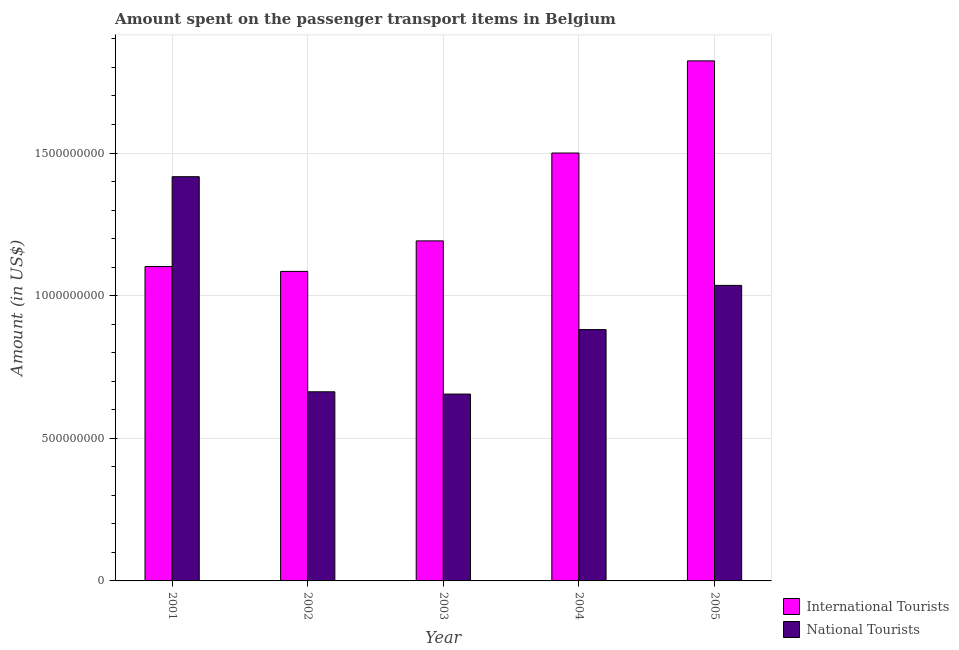How many different coloured bars are there?
Provide a succinct answer. 2. Are the number of bars on each tick of the X-axis equal?
Make the answer very short. Yes. How many bars are there on the 4th tick from the right?
Your answer should be compact. 2. In how many cases, is the number of bars for a given year not equal to the number of legend labels?
Offer a very short reply. 0. What is the amount spent on transport items of international tourists in 2002?
Your answer should be compact. 1.08e+09. Across all years, what is the maximum amount spent on transport items of national tourists?
Offer a very short reply. 1.42e+09. Across all years, what is the minimum amount spent on transport items of international tourists?
Make the answer very short. 1.08e+09. In which year was the amount spent on transport items of national tourists minimum?
Give a very brief answer. 2003. What is the total amount spent on transport items of international tourists in the graph?
Provide a succinct answer. 6.70e+09. What is the difference between the amount spent on transport items of international tourists in 2001 and that in 2005?
Offer a very short reply. -7.21e+08. What is the difference between the amount spent on transport items of national tourists in 2005 and the amount spent on transport items of international tourists in 2004?
Your answer should be compact. 1.55e+08. What is the average amount spent on transport items of international tourists per year?
Provide a succinct answer. 1.34e+09. In the year 2004, what is the difference between the amount spent on transport items of international tourists and amount spent on transport items of national tourists?
Offer a terse response. 0. In how many years, is the amount spent on transport items of international tourists greater than 300000000 US$?
Ensure brevity in your answer.  5. What is the ratio of the amount spent on transport items of international tourists in 2004 to that in 2005?
Your answer should be very brief. 0.82. Is the amount spent on transport items of international tourists in 2002 less than that in 2004?
Your response must be concise. Yes. What is the difference between the highest and the second highest amount spent on transport items of national tourists?
Ensure brevity in your answer.  3.81e+08. What is the difference between the highest and the lowest amount spent on transport items of international tourists?
Offer a very short reply. 7.38e+08. What does the 1st bar from the left in 2005 represents?
Provide a succinct answer. International Tourists. What does the 2nd bar from the right in 2002 represents?
Your answer should be very brief. International Tourists. How many bars are there?
Make the answer very short. 10. Are all the bars in the graph horizontal?
Your answer should be very brief. No. How many years are there in the graph?
Offer a very short reply. 5. What is the difference between two consecutive major ticks on the Y-axis?
Provide a short and direct response. 5.00e+08. Are the values on the major ticks of Y-axis written in scientific E-notation?
Offer a very short reply. No. Does the graph contain any zero values?
Keep it short and to the point. No. Where does the legend appear in the graph?
Offer a terse response. Bottom right. How are the legend labels stacked?
Keep it short and to the point. Vertical. What is the title of the graph?
Your answer should be very brief. Amount spent on the passenger transport items in Belgium. What is the label or title of the X-axis?
Provide a short and direct response. Year. What is the label or title of the Y-axis?
Keep it short and to the point. Amount (in US$). What is the Amount (in US$) in International Tourists in 2001?
Offer a very short reply. 1.10e+09. What is the Amount (in US$) of National Tourists in 2001?
Your answer should be very brief. 1.42e+09. What is the Amount (in US$) of International Tourists in 2002?
Offer a terse response. 1.08e+09. What is the Amount (in US$) of National Tourists in 2002?
Provide a short and direct response. 6.63e+08. What is the Amount (in US$) of International Tourists in 2003?
Keep it short and to the point. 1.19e+09. What is the Amount (in US$) of National Tourists in 2003?
Provide a succinct answer. 6.55e+08. What is the Amount (in US$) in International Tourists in 2004?
Your answer should be very brief. 1.50e+09. What is the Amount (in US$) of National Tourists in 2004?
Give a very brief answer. 8.81e+08. What is the Amount (in US$) in International Tourists in 2005?
Offer a terse response. 1.82e+09. What is the Amount (in US$) of National Tourists in 2005?
Your answer should be very brief. 1.04e+09. Across all years, what is the maximum Amount (in US$) in International Tourists?
Provide a succinct answer. 1.82e+09. Across all years, what is the maximum Amount (in US$) of National Tourists?
Your answer should be compact. 1.42e+09. Across all years, what is the minimum Amount (in US$) of International Tourists?
Keep it short and to the point. 1.08e+09. Across all years, what is the minimum Amount (in US$) in National Tourists?
Keep it short and to the point. 6.55e+08. What is the total Amount (in US$) of International Tourists in the graph?
Provide a short and direct response. 6.70e+09. What is the total Amount (in US$) of National Tourists in the graph?
Ensure brevity in your answer.  4.65e+09. What is the difference between the Amount (in US$) in International Tourists in 2001 and that in 2002?
Make the answer very short. 1.70e+07. What is the difference between the Amount (in US$) of National Tourists in 2001 and that in 2002?
Offer a very short reply. 7.54e+08. What is the difference between the Amount (in US$) of International Tourists in 2001 and that in 2003?
Your answer should be very brief. -9.00e+07. What is the difference between the Amount (in US$) in National Tourists in 2001 and that in 2003?
Your answer should be compact. 7.62e+08. What is the difference between the Amount (in US$) in International Tourists in 2001 and that in 2004?
Provide a succinct answer. -3.98e+08. What is the difference between the Amount (in US$) in National Tourists in 2001 and that in 2004?
Provide a short and direct response. 5.36e+08. What is the difference between the Amount (in US$) in International Tourists in 2001 and that in 2005?
Provide a short and direct response. -7.21e+08. What is the difference between the Amount (in US$) in National Tourists in 2001 and that in 2005?
Make the answer very short. 3.81e+08. What is the difference between the Amount (in US$) of International Tourists in 2002 and that in 2003?
Your response must be concise. -1.07e+08. What is the difference between the Amount (in US$) of International Tourists in 2002 and that in 2004?
Your answer should be compact. -4.15e+08. What is the difference between the Amount (in US$) of National Tourists in 2002 and that in 2004?
Your response must be concise. -2.18e+08. What is the difference between the Amount (in US$) of International Tourists in 2002 and that in 2005?
Keep it short and to the point. -7.38e+08. What is the difference between the Amount (in US$) of National Tourists in 2002 and that in 2005?
Your answer should be very brief. -3.73e+08. What is the difference between the Amount (in US$) in International Tourists in 2003 and that in 2004?
Offer a very short reply. -3.08e+08. What is the difference between the Amount (in US$) of National Tourists in 2003 and that in 2004?
Your answer should be compact. -2.26e+08. What is the difference between the Amount (in US$) in International Tourists in 2003 and that in 2005?
Your response must be concise. -6.31e+08. What is the difference between the Amount (in US$) in National Tourists in 2003 and that in 2005?
Offer a terse response. -3.81e+08. What is the difference between the Amount (in US$) of International Tourists in 2004 and that in 2005?
Your response must be concise. -3.23e+08. What is the difference between the Amount (in US$) of National Tourists in 2004 and that in 2005?
Make the answer very short. -1.55e+08. What is the difference between the Amount (in US$) of International Tourists in 2001 and the Amount (in US$) of National Tourists in 2002?
Provide a succinct answer. 4.39e+08. What is the difference between the Amount (in US$) in International Tourists in 2001 and the Amount (in US$) in National Tourists in 2003?
Offer a terse response. 4.47e+08. What is the difference between the Amount (in US$) of International Tourists in 2001 and the Amount (in US$) of National Tourists in 2004?
Provide a short and direct response. 2.21e+08. What is the difference between the Amount (in US$) in International Tourists in 2001 and the Amount (in US$) in National Tourists in 2005?
Your response must be concise. 6.60e+07. What is the difference between the Amount (in US$) of International Tourists in 2002 and the Amount (in US$) of National Tourists in 2003?
Provide a succinct answer. 4.30e+08. What is the difference between the Amount (in US$) in International Tourists in 2002 and the Amount (in US$) in National Tourists in 2004?
Provide a short and direct response. 2.04e+08. What is the difference between the Amount (in US$) in International Tourists in 2002 and the Amount (in US$) in National Tourists in 2005?
Offer a very short reply. 4.90e+07. What is the difference between the Amount (in US$) in International Tourists in 2003 and the Amount (in US$) in National Tourists in 2004?
Offer a terse response. 3.11e+08. What is the difference between the Amount (in US$) in International Tourists in 2003 and the Amount (in US$) in National Tourists in 2005?
Give a very brief answer. 1.56e+08. What is the difference between the Amount (in US$) in International Tourists in 2004 and the Amount (in US$) in National Tourists in 2005?
Make the answer very short. 4.64e+08. What is the average Amount (in US$) of International Tourists per year?
Your answer should be very brief. 1.34e+09. What is the average Amount (in US$) of National Tourists per year?
Your answer should be very brief. 9.30e+08. In the year 2001, what is the difference between the Amount (in US$) in International Tourists and Amount (in US$) in National Tourists?
Offer a very short reply. -3.15e+08. In the year 2002, what is the difference between the Amount (in US$) in International Tourists and Amount (in US$) in National Tourists?
Your response must be concise. 4.22e+08. In the year 2003, what is the difference between the Amount (in US$) of International Tourists and Amount (in US$) of National Tourists?
Offer a very short reply. 5.37e+08. In the year 2004, what is the difference between the Amount (in US$) in International Tourists and Amount (in US$) in National Tourists?
Provide a short and direct response. 6.19e+08. In the year 2005, what is the difference between the Amount (in US$) of International Tourists and Amount (in US$) of National Tourists?
Keep it short and to the point. 7.87e+08. What is the ratio of the Amount (in US$) in International Tourists in 2001 to that in 2002?
Your answer should be very brief. 1.02. What is the ratio of the Amount (in US$) in National Tourists in 2001 to that in 2002?
Ensure brevity in your answer.  2.14. What is the ratio of the Amount (in US$) in International Tourists in 2001 to that in 2003?
Provide a short and direct response. 0.92. What is the ratio of the Amount (in US$) in National Tourists in 2001 to that in 2003?
Provide a succinct answer. 2.16. What is the ratio of the Amount (in US$) in International Tourists in 2001 to that in 2004?
Offer a terse response. 0.73. What is the ratio of the Amount (in US$) in National Tourists in 2001 to that in 2004?
Offer a terse response. 1.61. What is the ratio of the Amount (in US$) in International Tourists in 2001 to that in 2005?
Keep it short and to the point. 0.6. What is the ratio of the Amount (in US$) in National Tourists in 2001 to that in 2005?
Give a very brief answer. 1.37. What is the ratio of the Amount (in US$) of International Tourists in 2002 to that in 2003?
Ensure brevity in your answer.  0.91. What is the ratio of the Amount (in US$) in National Tourists in 2002 to that in 2003?
Your answer should be very brief. 1.01. What is the ratio of the Amount (in US$) in International Tourists in 2002 to that in 2004?
Offer a terse response. 0.72. What is the ratio of the Amount (in US$) in National Tourists in 2002 to that in 2004?
Ensure brevity in your answer.  0.75. What is the ratio of the Amount (in US$) in International Tourists in 2002 to that in 2005?
Your answer should be very brief. 0.6. What is the ratio of the Amount (in US$) in National Tourists in 2002 to that in 2005?
Offer a very short reply. 0.64. What is the ratio of the Amount (in US$) in International Tourists in 2003 to that in 2004?
Your response must be concise. 0.79. What is the ratio of the Amount (in US$) of National Tourists in 2003 to that in 2004?
Provide a short and direct response. 0.74. What is the ratio of the Amount (in US$) of International Tourists in 2003 to that in 2005?
Your answer should be very brief. 0.65. What is the ratio of the Amount (in US$) of National Tourists in 2003 to that in 2005?
Offer a very short reply. 0.63. What is the ratio of the Amount (in US$) of International Tourists in 2004 to that in 2005?
Offer a terse response. 0.82. What is the ratio of the Amount (in US$) of National Tourists in 2004 to that in 2005?
Keep it short and to the point. 0.85. What is the difference between the highest and the second highest Amount (in US$) in International Tourists?
Ensure brevity in your answer.  3.23e+08. What is the difference between the highest and the second highest Amount (in US$) of National Tourists?
Ensure brevity in your answer.  3.81e+08. What is the difference between the highest and the lowest Amount (in US$) of International Tourists?
Provide a short and direct response. 7.38e+08. What is the difference between the highest and the lowest Amount (in US$) of National Tourists?
Ensure brevity in your answer.  7.62e+08. 